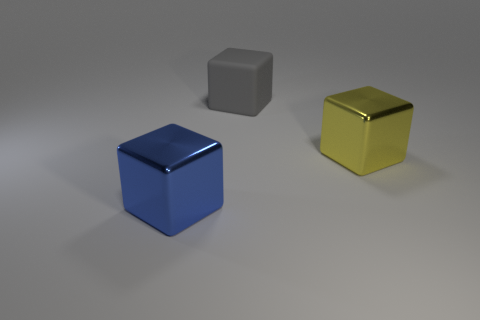Is there any other thing that is the same material as the gray thing?
Keep it short and to the point. No. Is the number of blocks that are in front of the big yellow metallic thing greater than the number of blue objects that are on the right side of the big matte thing?
Offer a very short reply. Yes. How many large rubber blocks are behind the big blue thing to the left of the big yellow block?
Provide a short and direct response. 1. There is a large metal thing that is right of the large blue metal thing; does it have the same shape as the large gray rubber thing?
Offer a very short reply. Yes. There is a large blue object that is the same shape as the yellow object; what is it made of?
Provide a short and direct response. Metal. What number of rubber objects are the same size as the blue cube?
Offer a terse response. 1. There is a object that is both in front of the gray matte thing and on the left side of the large yellow metal thing; what color is it?
Your answer should be very brief. Blue. Is the number of big blue shiny cubes less than the number of large blocks?
Provide a short and direct response. Yes. Is the number of yellow metal blocks behind the big gray rubber thing the same as the number of blue cubes that are behind the yellow thing?
Provide a short and direct response. Yes. What number of blue metal objects are the same shape as the large gray matte object?
Offer a very short reply. 1. 